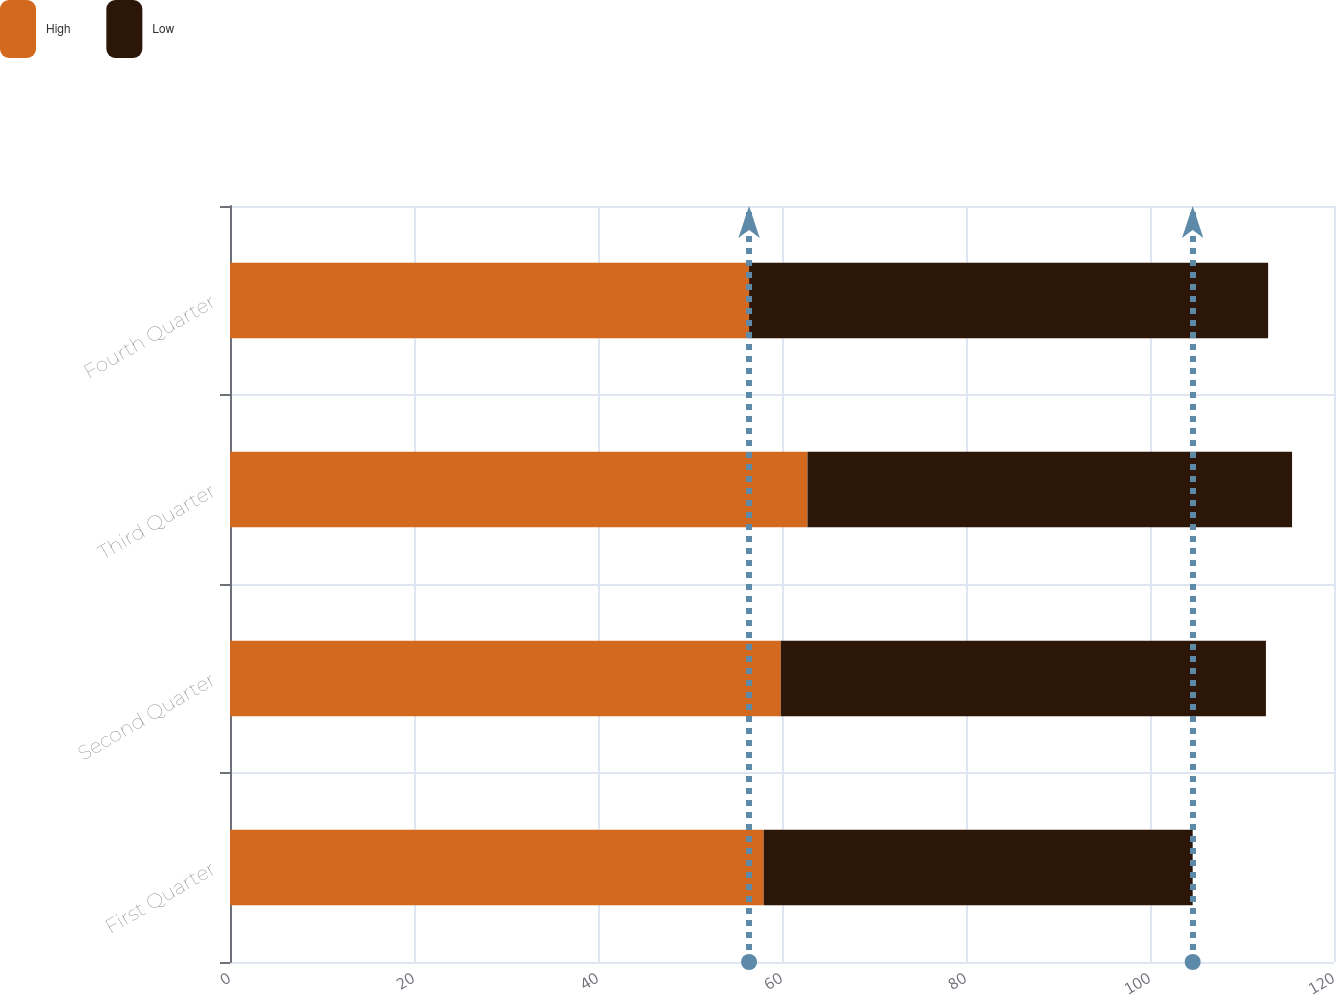Convert chart. <chart><loc_0><loc_0><loc_500><loc_500><stacked_bar_chart><ecel><fcel>First Quarter<fcel>Second Quarter<fcel>Third Quarter<fcel>Fourth Quarter<nl><fcel>High<fcel>58.01<fcel>59.87<fcel>62.77<fcel>56.42<nl><fcel>Low<fcel>46.63<fcel>52.73<fcel>52.67<fcel>56.42<nl></chart> 